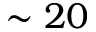<formula> <loc_0><loc_0><loc_500><loc_500>\sim 2 0</formula> 